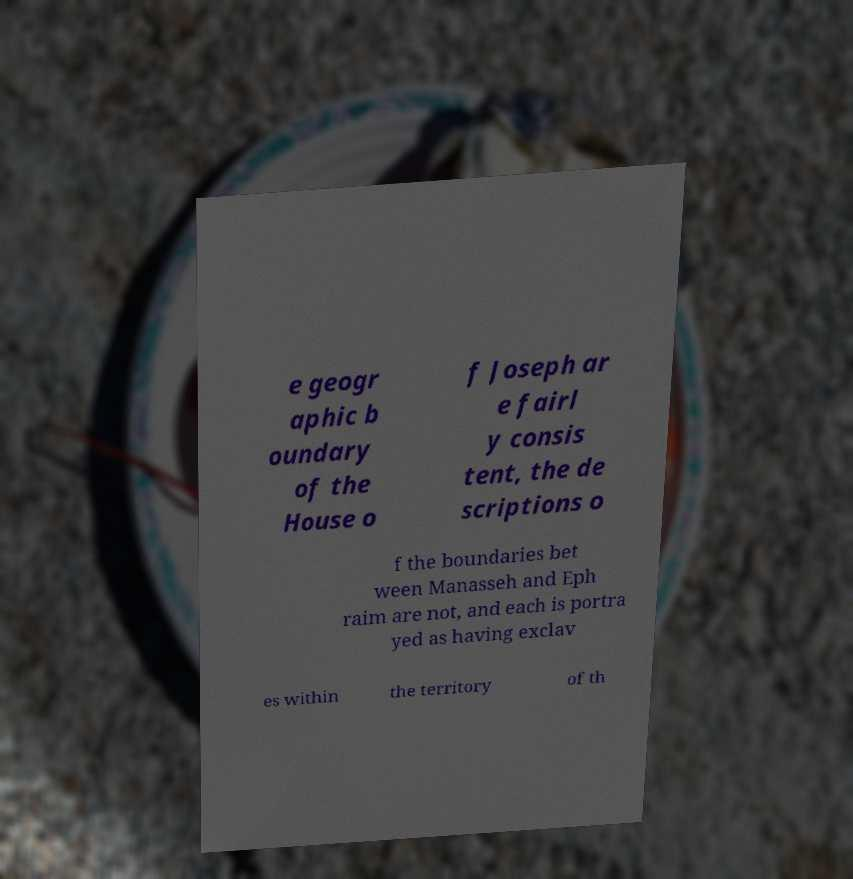What messages or text are displayed in this image? I need them in a readable, typed format. e geogr aphic b oundary of the House o f Joseph ar e fairl y consis tent, the de scriptions o f the boundaries bet ween Manasseh and Eph raim are not, and each is portra yed as having exclav es within the territory of th 